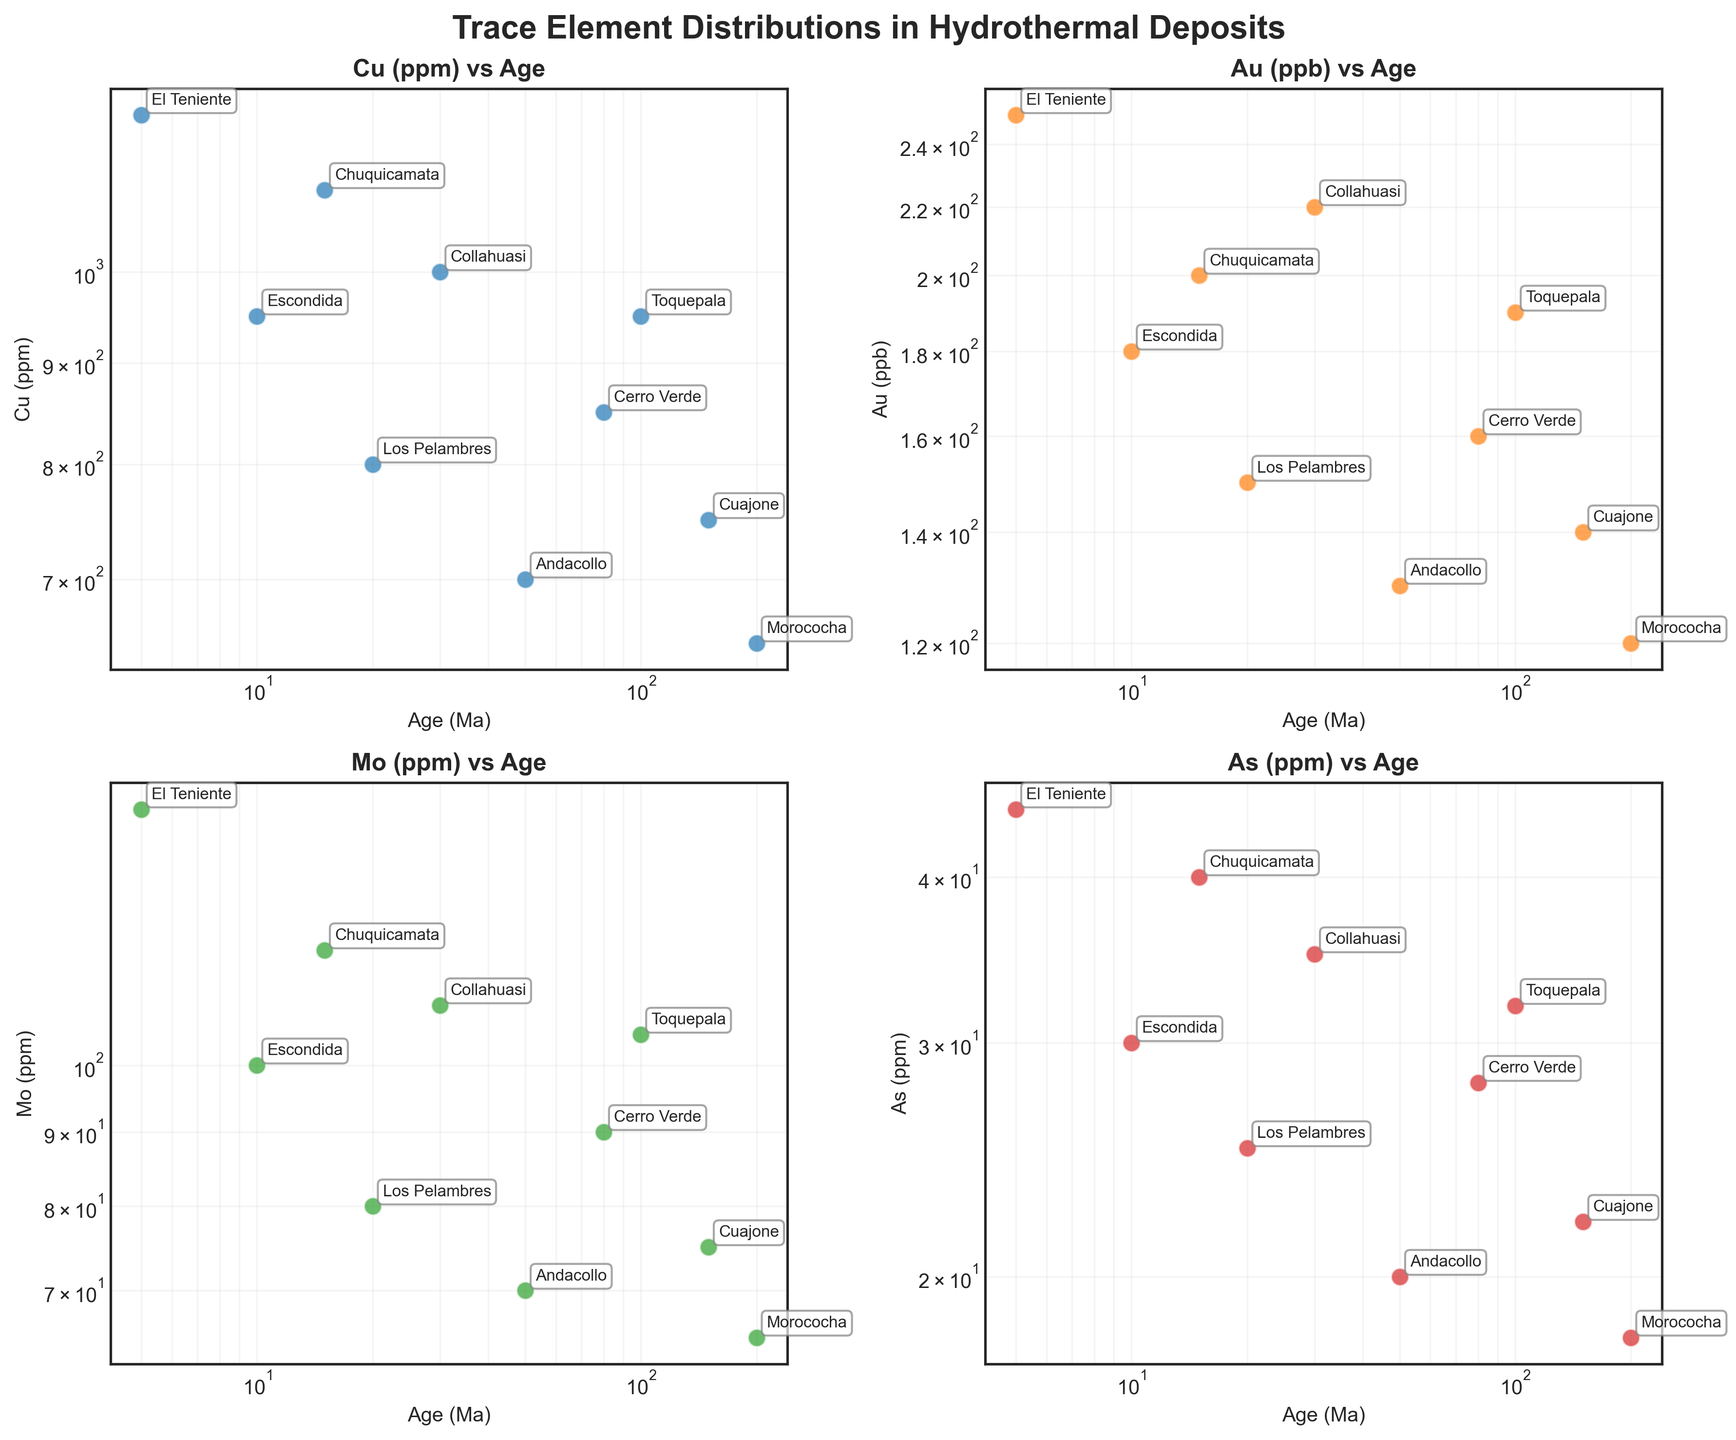What does the figure's title indicate? The title "Trace Element Distributions in Hydrothermal Deposits" indicates the focus of the scatter plot, which is on the distribution of trace elements in various hydrothermal deposits across different geological ages.
Answer: Trace Element Distributions in Hydrothermal Deposits What are the elements displayed on the y-axis in the subplots? Each subplot displays a different element on the y-axis: Copper (Cu), Gold (Au), Molybdenum (Mo), and Arsenic (As).
Answer: Copper (Cu), Gold (Au), Molybdenum (Mo), and Arsenic (As) How are the ages represented on the x-axis? The ages are represented on a logarithmic scale, as indicated by the log scale of the x-axis.
Answer: Logarithmic scale Which deposit has the highest Copper (Cu) concentration? By looking at the subplot for Copper (Cu), the deposit with the highest concentration is "El Teniente," which appears at the top of the y-axis.
Answer: El Teniente What's the trend of Gold (Au) concentration with age? From the subplot for Gold (Au), the trend shows that Au concentration does not follow a clear increasing or decreasing trend with age, as it varies irregularly across different ages.
Answer: No clear trend Which deposit is indicated at an age of 50 Ma across all subplots? By identifying the deposit labeled at the age of 50 Ma on the x-axis, it is "Andacollo."
Answer: Andacollo How does Molybdenum (Mo) concentration in Escondida compare to that in Cerro Verde? Comparing the Molybdenum (Mo) concentration points in the subplot, Escondida (age 10 Ma) has a higher concentration (100 ppm) than Cerro Verde (age 80 Ma, 90 ppm).
Answer: Escondida > Cerro Verde Is there a correlation visible between Arsenic (As) concentration and the Age (Ma)? By observing the subplot for Arsenic (As), there is no obvious correlation between As concentration and the geological age, as As concentration points are scattered without a clear pattern.
Answer: No obvious correlation What are the trends of Copper (Cu) and Molybdenum (Mo) concentrations with increasing age? For Copper (Cu), there isn't a clear trend, though there is a slight decrease with increasing age. For Molybdenum (Mo), the concentrations oscillate, also without a clear trend. Both elements do not show a simple increasing or decreasing pattern with age.
Answer: No clear trends 